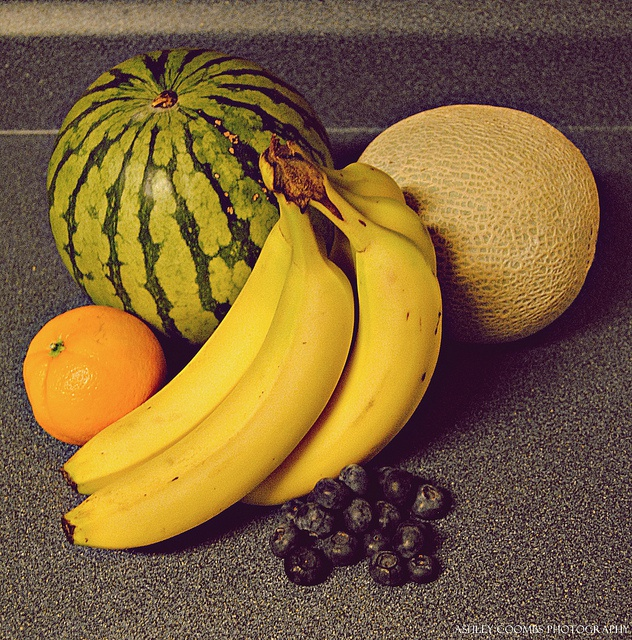Describe the objects in this image and their specific colors. I can see banana in black, orange, gold, and olive tones and orange in black, orange, red, brown, and maroon tones in this image. 